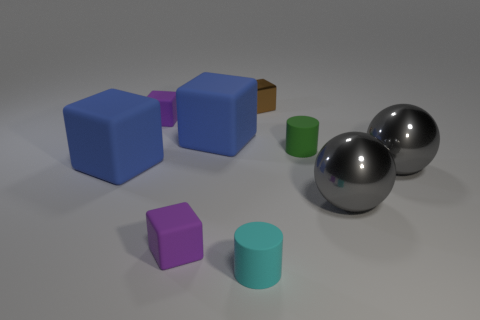Is the size of the cyan cylinder the same as the brown object?
Give a very brief answer. Yes. How many things are either tiny cyan rubber cylinders or large rubber blocks?
Keep it short and to the point. 3. Is there a blue thing that has the same shape as the small brown metal object?
Make the answer very short. Yes. What shape is the purple matte thing in front of the blue rubber block in front of the small green matte cylinder?
Provide a short and direct response. Cube. Is there a purple rubber thing of the same size as the green object?
Offer a terse response. Yes. Is the number of green cylinders less than the number of large matte spheres?
Your answer should be compact. No. The blue matte thing that is on the right side of the tiny purple rubber thing in front of the green object that is right of the tiny brown cube is what shape?
Ensure brevity in your answer.  Cube. How many things are objects left of the brown thing or tiny purple rubber blocks that are in front of the green cylinder?
Keep it short and to the point. 5. Are there any cubes behind the tiny green rubber cylinder?
Give a very brief answer. Yes. What number of objects are big rubber objects that are in front of the small green rubber thing or gray spheres?
Give a very brief answer. 3. 